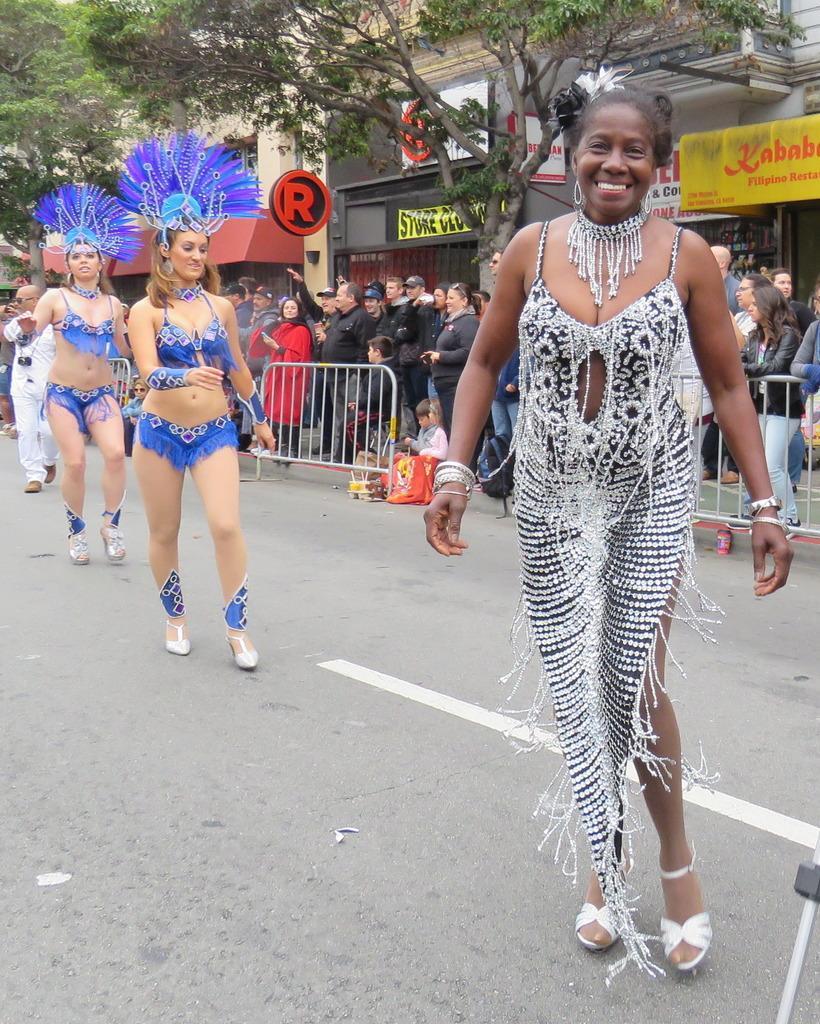Could you give a brief overview of what you see in this image? In this image there are women wearing costumes and walking on a road, in the background there are railings, behind the railing there are people standing and there are trees and buildings. 